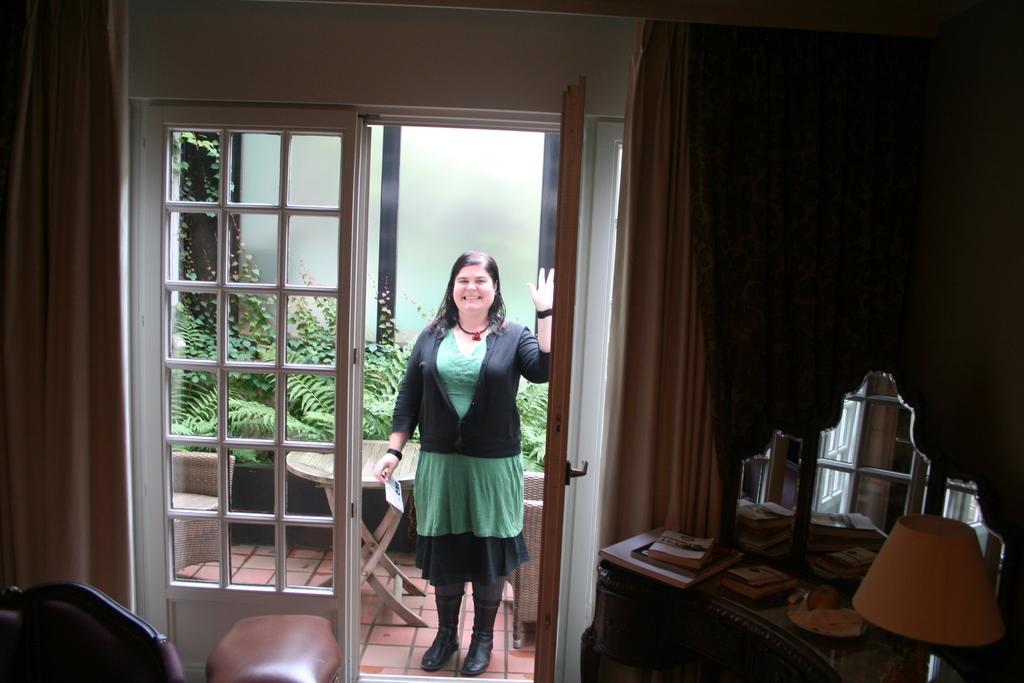Could you give a brief overview of what you see in this image? In this image there is a woman smiling and holding a card and standing on the floor. Image also consists of books, lamp, curtains, chair and also door. We can see the window and behind the window there are chairs and table and also plants. 